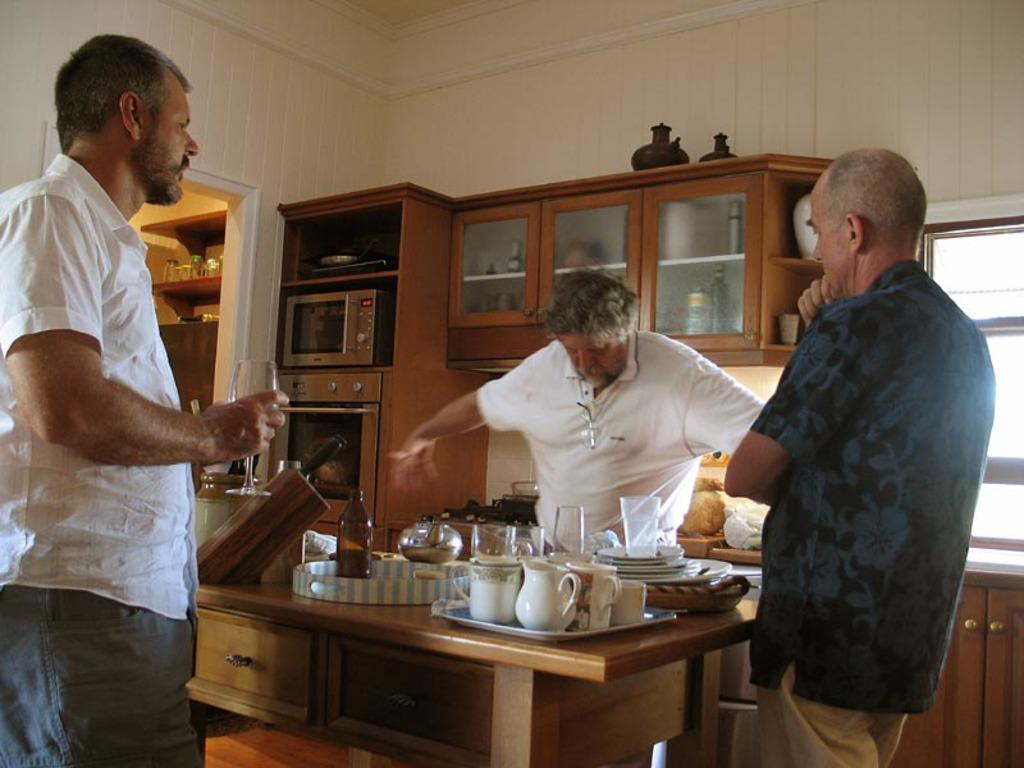How many people are in the image? There is a group of people in the image, but the exact number is not specified. What are the people in the image doing? The people are standing in the image. What can be seen in the background of the image? There are shelves in the background of the image. Where is the dock located in the image? There is no dock present in the image. How many chickens are in the image? There are no chickens present in the image. 